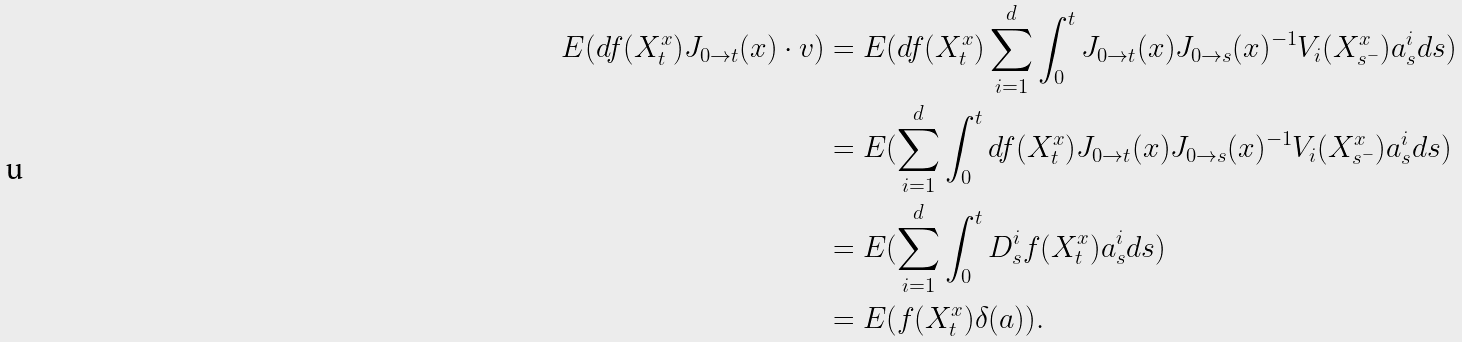<formula> <loc_0><loc_0><loc_500><loc_500>E ( d f ( X _ { t } ^ { x } ) J _ { 0 \to t } ( x ) \cdot v ) & = E ( d f ( X _ { t } ^ { x } ) \sum _ { i = 1 } ^ { d } \int _ { 0 } ^ { t } J _ { 0 \to t } ( x ) J _ { 0 \to s } ( x ) ^ { - 1 } V _ { i } ( X _ { s ^ { - } } ^ { x } ) a _ { s } ^ { i } d s ) \\ & = E ( \sum _ { i = 1 } ^ { d } \int _ { 0 } ^ { t } d f ( X _ { t } ^ { x } ) J _ { 0 \to t } ( x ) J _ { 0 \to s } ( x ) ^ { - 1 } V _ { i } ( X _ { s ^ { - } } ^ { x } ) a _ { s } ^ { i } d s ) \\ & = E ( \sum _ { i = 1 } ^ { d } \int _ { 0 } ^ { t } D _ { s } ^ { i } f ( X _ { t } ^ { x } ) a _ { s } ^ { i } d s ) \\ & = E ( f ( X _ { t } ^ { x } ) \delta ( a ) ) .</formula> 